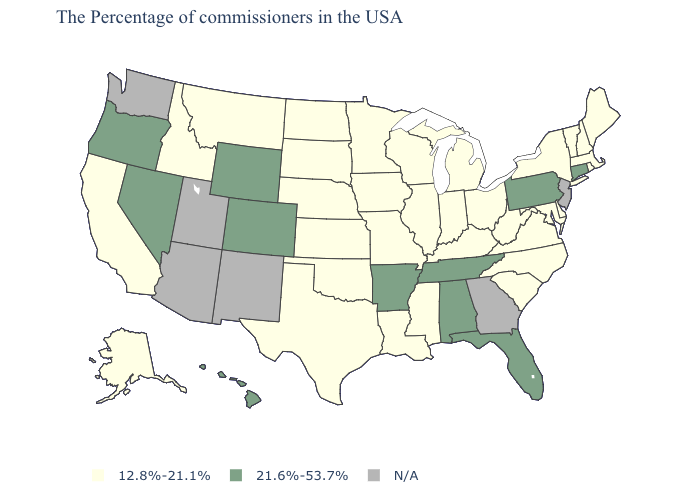Name the states that have a value in the range 21.6%-53.7%?
Quick response, please. Connecticut, Pennsylvania, Florida, Alabama, Tennessee, Arkansas, Wyoming, Colorado, Nevada, Oregon, Hawaii. Name the states that have a value in the range 21.6%-53.7%?
Quick response, please. Connecticut, Pennsylvania, Florida, Alabama, Tennessee, Arkansas, Wyoming, Colorado, Nevada, Oregon, Hawaii. Among the states that border Utah , which have the highest value?
Short answer required. Wyoming, Colorado, Nevada. Name the states that have a value in the range N/A?
Concise answer only. New Jersey, Georgia, New Mexico, Utah, Arizona, Washington. What is the value of Arizona?
Answer briefly. N/A. Does Iowa have the highest value in the USA?
Write a very short answer. No. What is the highest value in the USA?
Quick response, please. 21.6%-53.7%. Does California have the highest value in the West?
Be succinct. No. Does New Hampshire have the lowest value in the Northeast?
Quick response, please. Yes. Which states hav the highest value in the South?
Keep it brief. Florida, Alabama, Tennessee, Arkansas. Name the states that have a value in the range 21.6%-53.7%?
Answer briefly. Connecticut, Pennsylvania, Florida, Alabama, Tennessee, Arkansas, Wyoming, Colorado, Nevada, Oregon, Hawaii. Name the states that have a value in the range 12.8%-21.1%?
Concise answer only. Maine, Massachusetts, Rhode Island, New Hampshire, Vermont, New York, Delaware, Maryland, Virginia, North Carolina, South Carolina, West Virginia, Ohio, Michigan, Kentucky, Indiana, Wisconsin, Illinois, Mississippi, Louisiana, Missouri, Minnesota, Iowa, Kansas, Nebraska, Oklahoma, Texas, South Dakota, North Dakota, Montana, Idaho, California, Alaska. Which states have the lowest value in the USA?
Concise answer only. Maine, Massachusetts, Rhode Island, New Hampshire, Vermont, New York, Delaware, Maryland, Virginia, North Carolina, South Carolina, West Virginia, Ohio, Michigan, Kentucky, Indiana, Wisconsin, Illinois, Mississippi, Louisiana, Missouri, Minnesota, Iowa, Kansas, Nebraska, Oklahoma, Texas, South Dakota, North Dakota, Montana, Idaho, California, Alaska. Does the map have missing data?
Concise answer only. Yes. What is the highest value in the Northeast ?
Answer briefly. 21.6%-53.7%. 